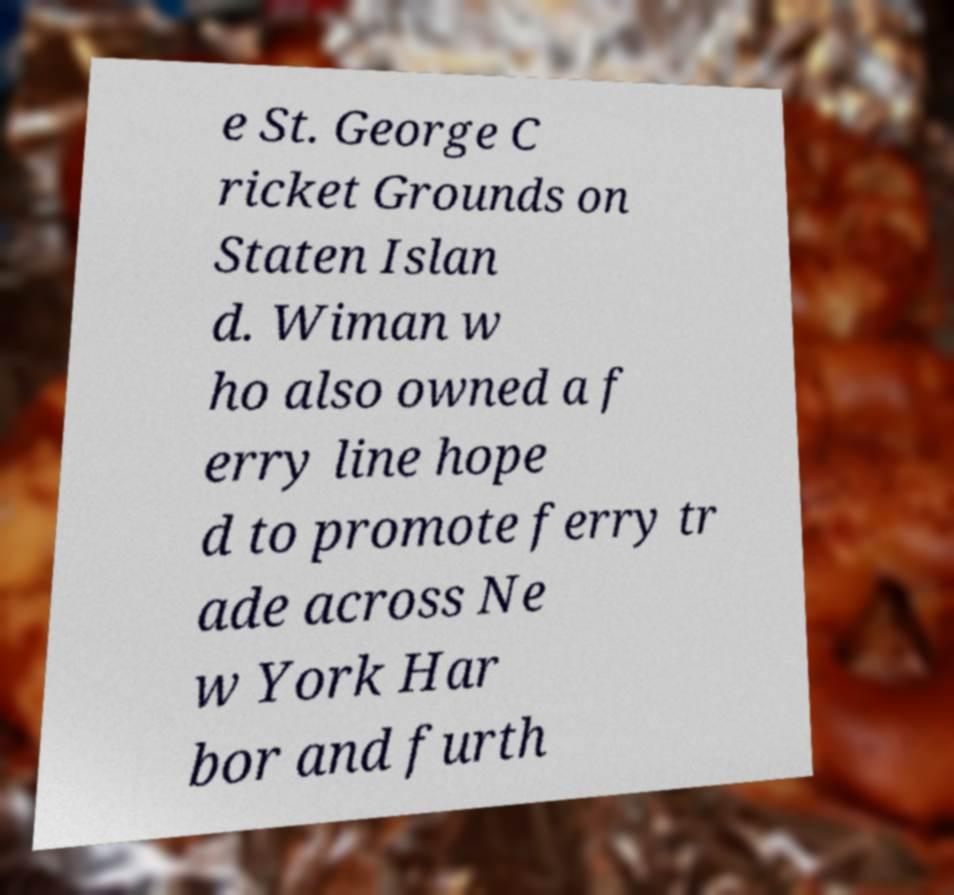I need the written content from this picture converted into text. Can you do that? e St. George C ricket Grounds on Staten Islan d. Wiman w ho also owned a f erry line hope d to promote ferry tr ade across Ne w York Har bor and furth 